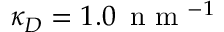<formula> <loc_0><loc_0><loc_500><loc_500>\kappa _ { D } = 1 . 0 \, n m ^ { - 1 }</formula> 